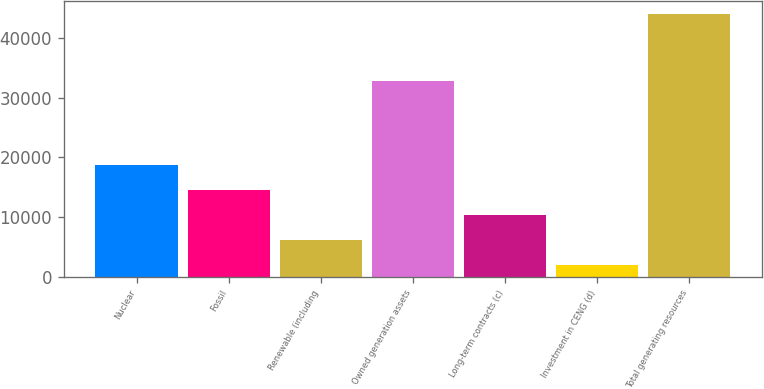Convert chart. <chart><loc_0><loc_0><loc_500><loc_500><bar_chart><fcel>Nuclear<fcel>Fossil<fcel>Renewable (including<fcel>Owned generation assets<fcel>Long-term contracts (c)<fcel>Investment in CENG (d)<fcel>Total generating resources<nl><fcel>18788.6<fcel>14582.2<fcel>6169.4<fcel>32768<fcel>10375.8<fcel>1963<fcel>44027<nl></chart> 